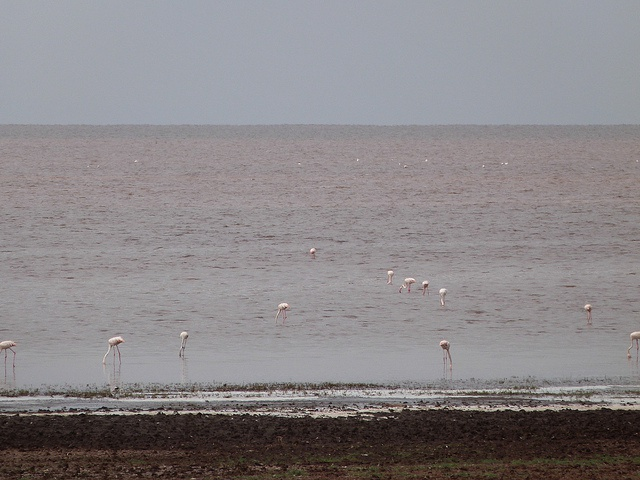Describe the objects in this image and their specific colors. I can see bird in darkgray, gray, and pink tones, bird in darkgray and gray tones, bird in darkgray, gray, and lightgray tones, bird in darkgray and gray tones, and bird in darkgray and gray tones in this image. 